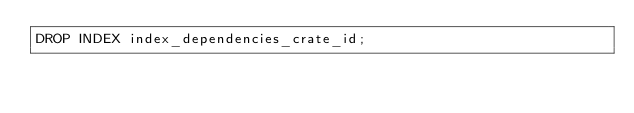Convert code to text. <code><loc_0><loc_0><loc_500><loc_500><_SQL_>DROP INDEX index_dependencies_crate_id;</code> 